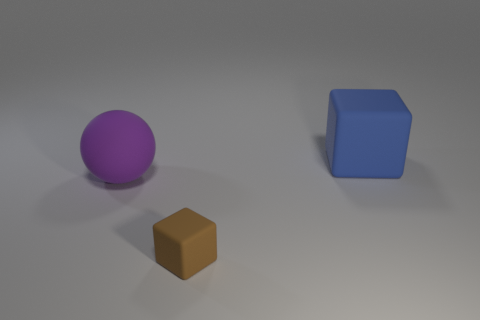If these objects were part of a game, what roles do you think they could play? If this was a game setting, the different shapes and colors could serve unique roles. For instance, the purple sphere might be a ball used to score points, the blue cube could be an element to solve puzzles or construct paths, and the brown object might be a collectible or a resource the player needs to gather to progress. 